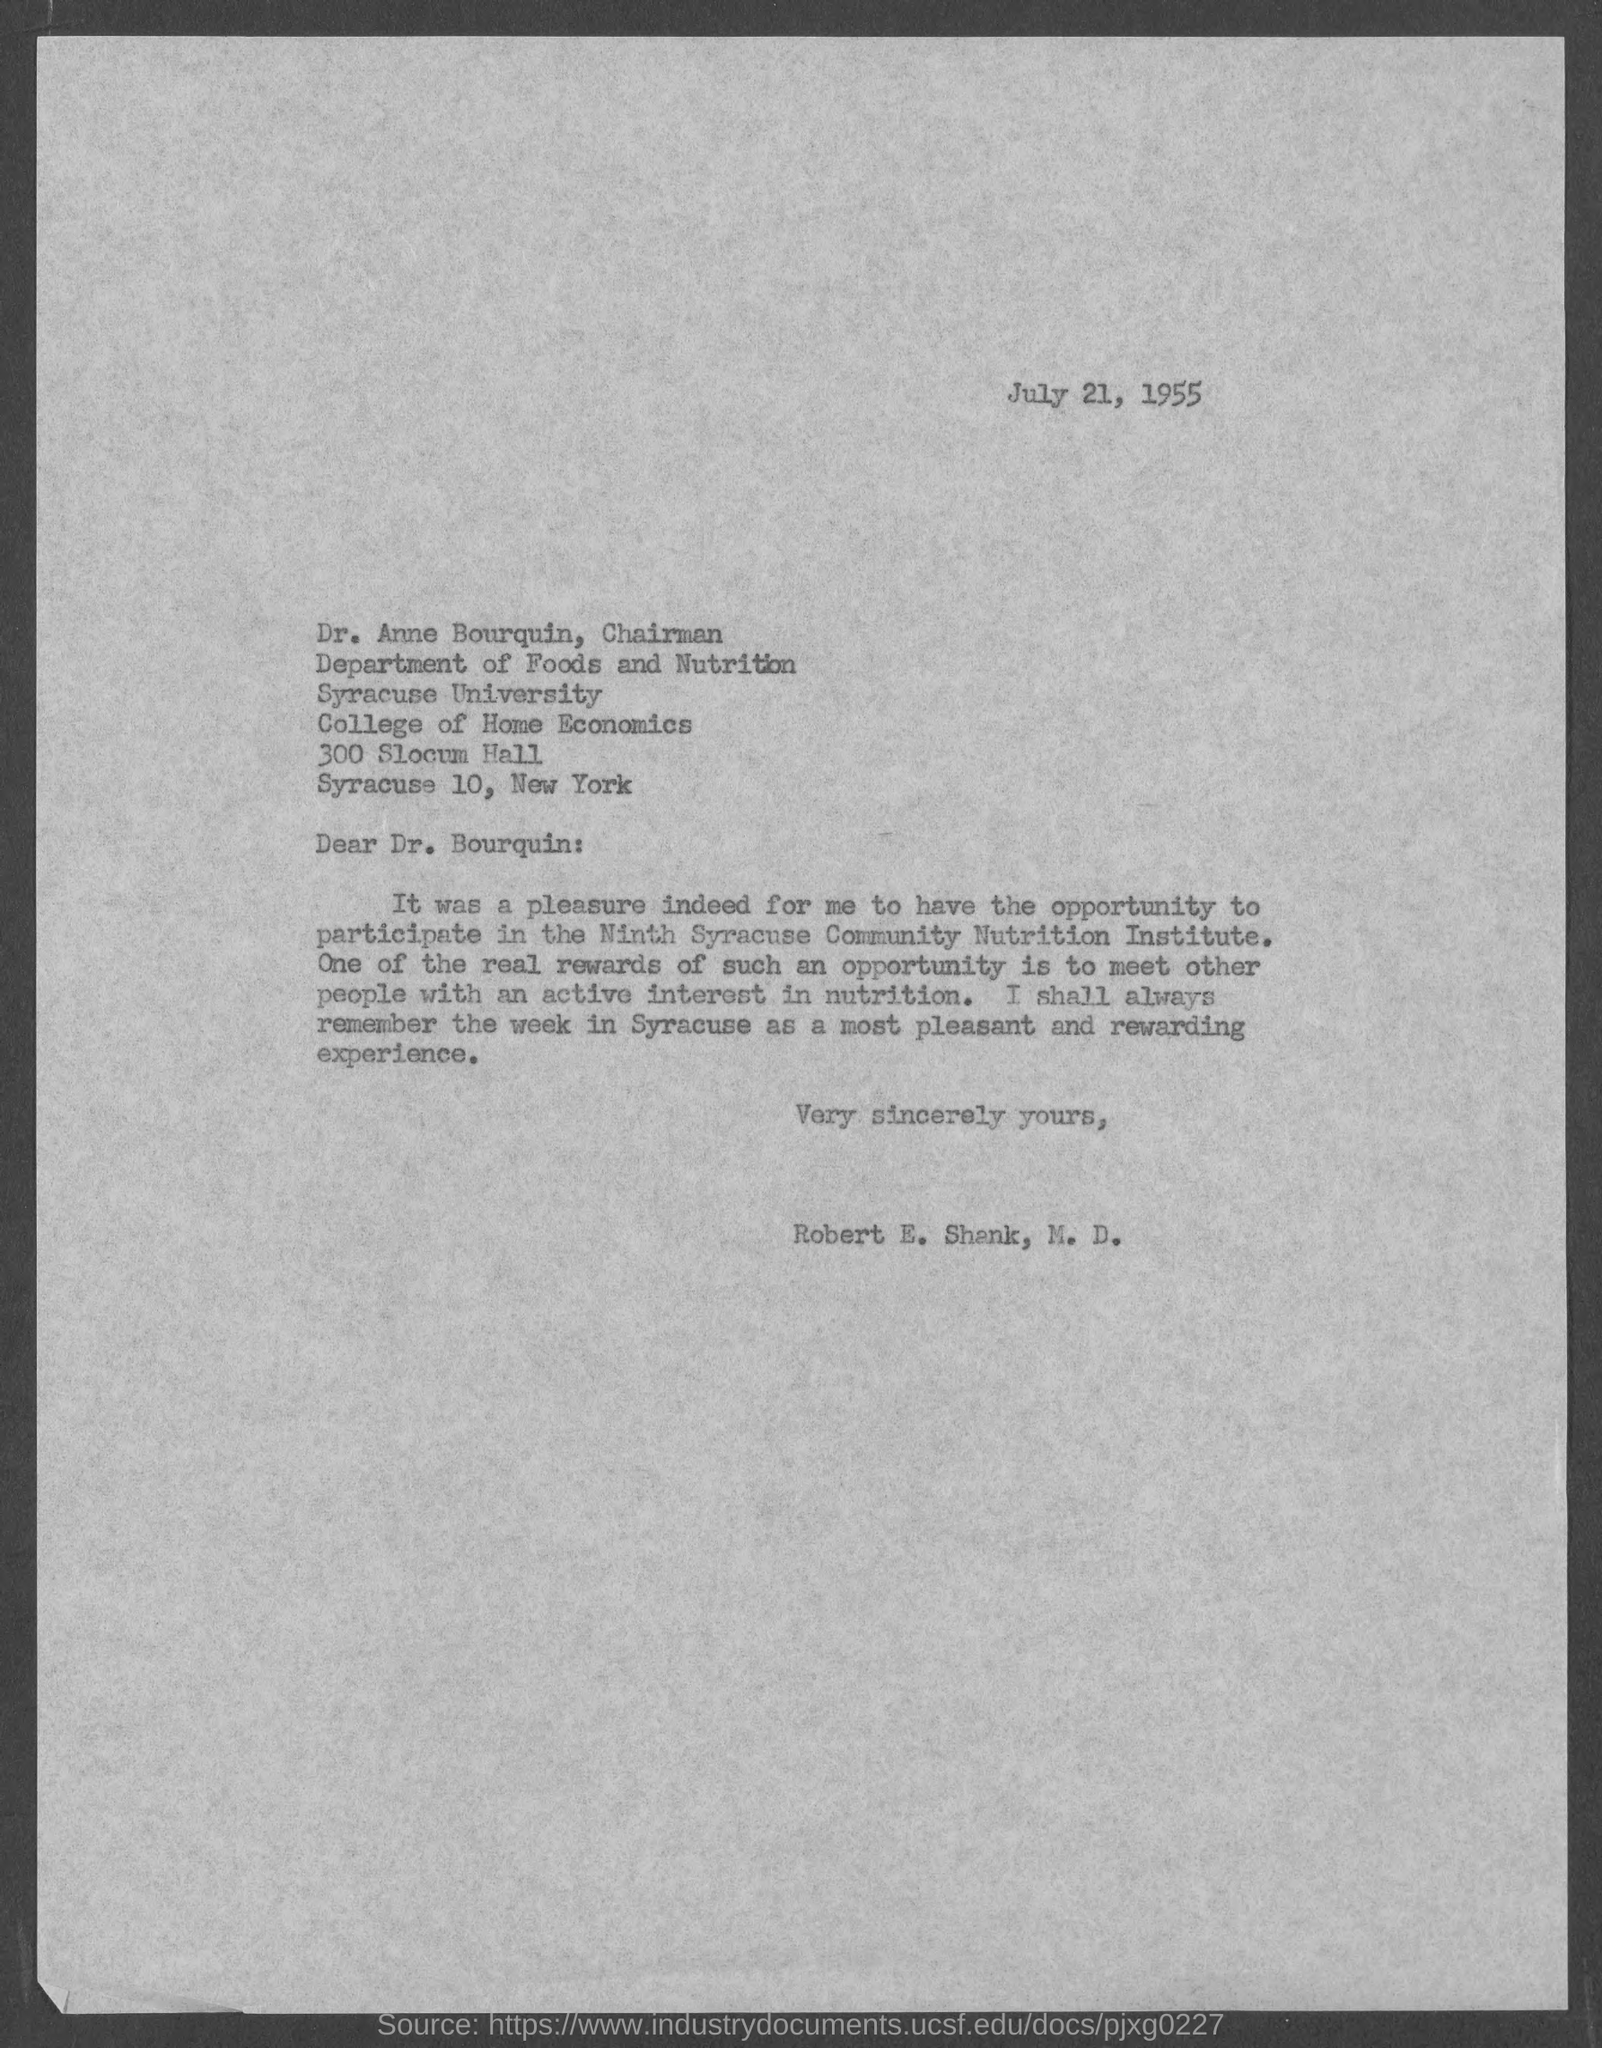Point out several critical features in this image. The salutation of this letter is "Dear... On July 21, 1955, the date was. 